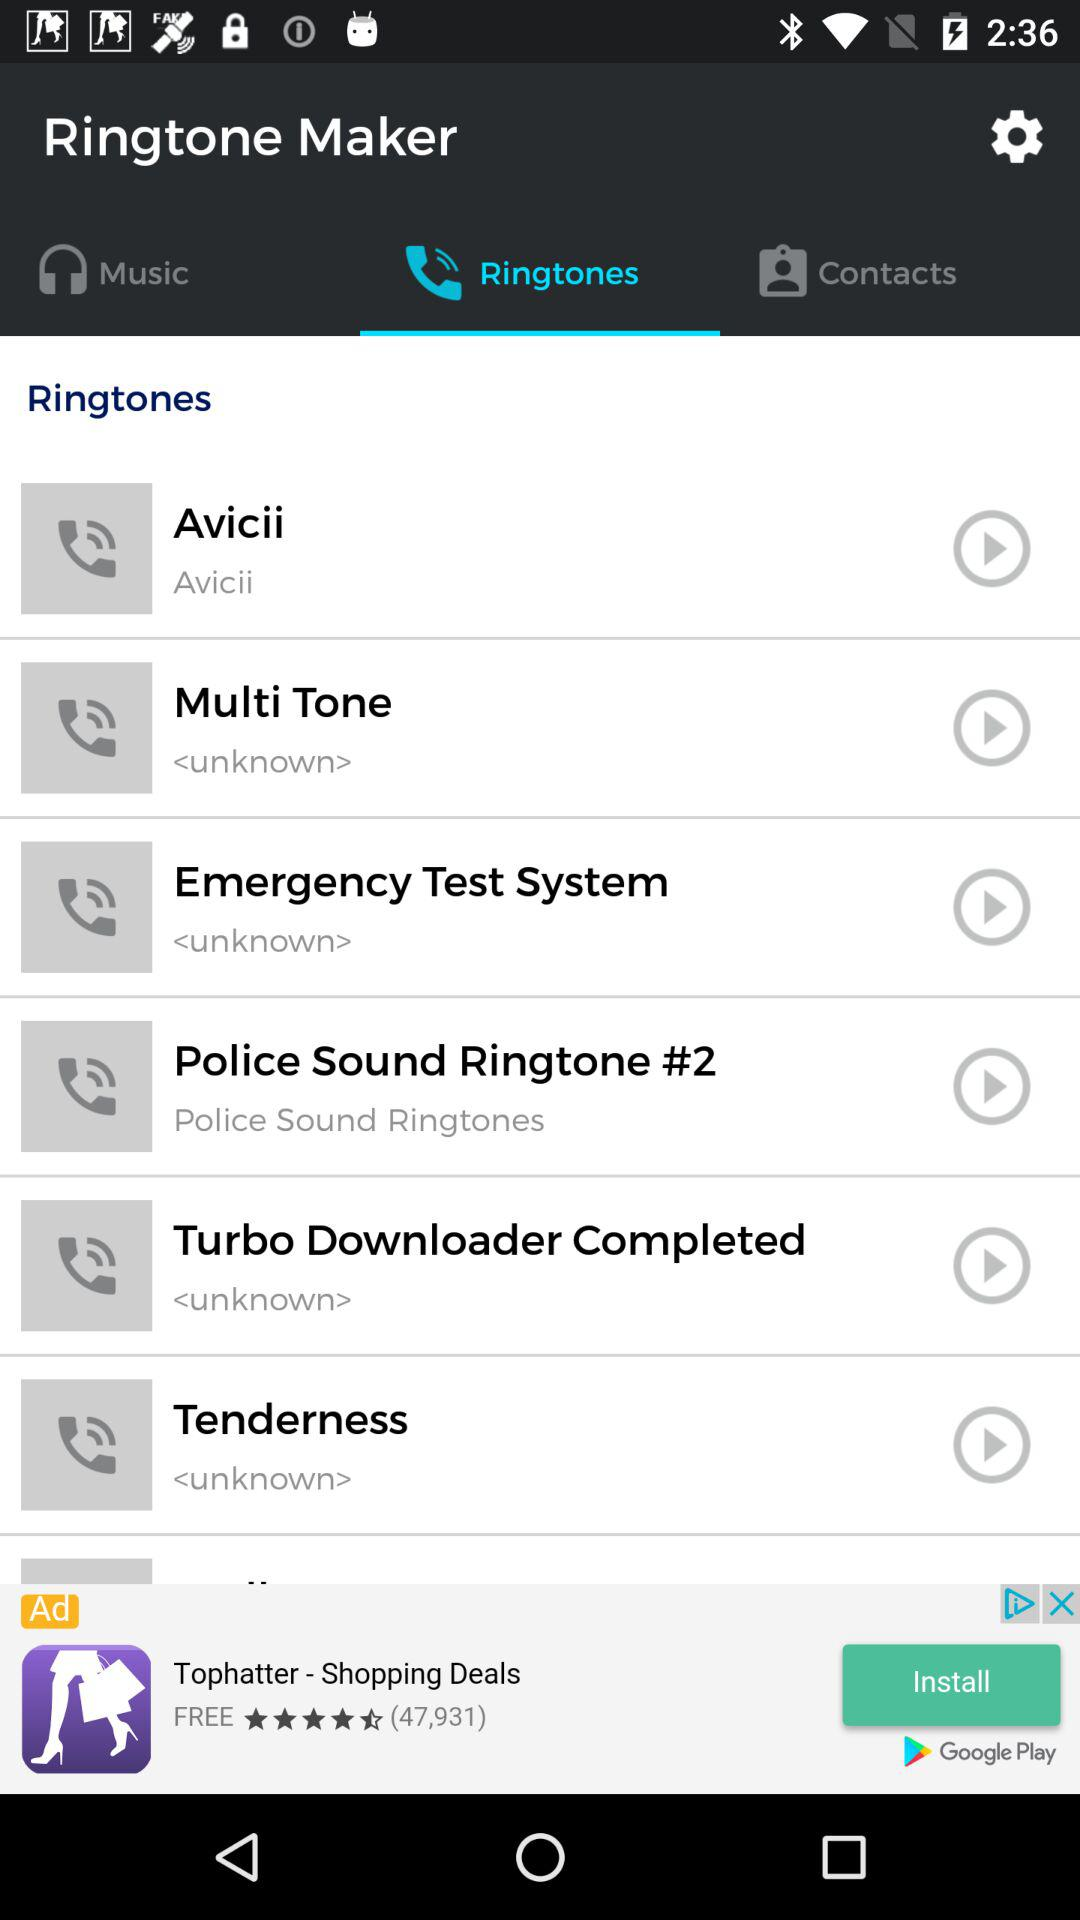What is the application name? The application name is "Ringtone Maker". 